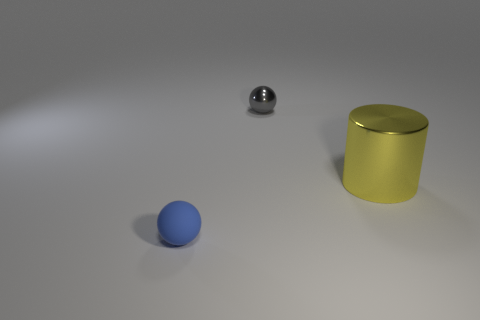Subtract all blue cylinders. Subtract all blue cubes. How many cylinders are left? 1 Add 2 tiny green rubber cubes. How many objects exist? 5 Subtract all cylinders. How many objects are left? 2 Subtract all large metallic cylinders. Subtract all small blue rubber balls. How many objects are left? 1 Add 3 tiny balls. How many tiny balls are left? 5 Add 2 big brown balls. How many big brown balls exist? 2 Subtract 0 brown balls. How many objects are left? 3 